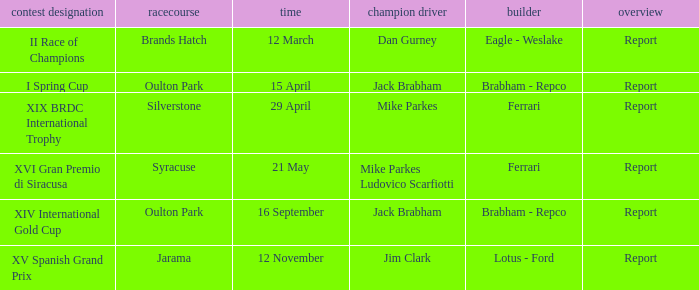What is the name of the race on 16 september? XIV International Gold Cup. 